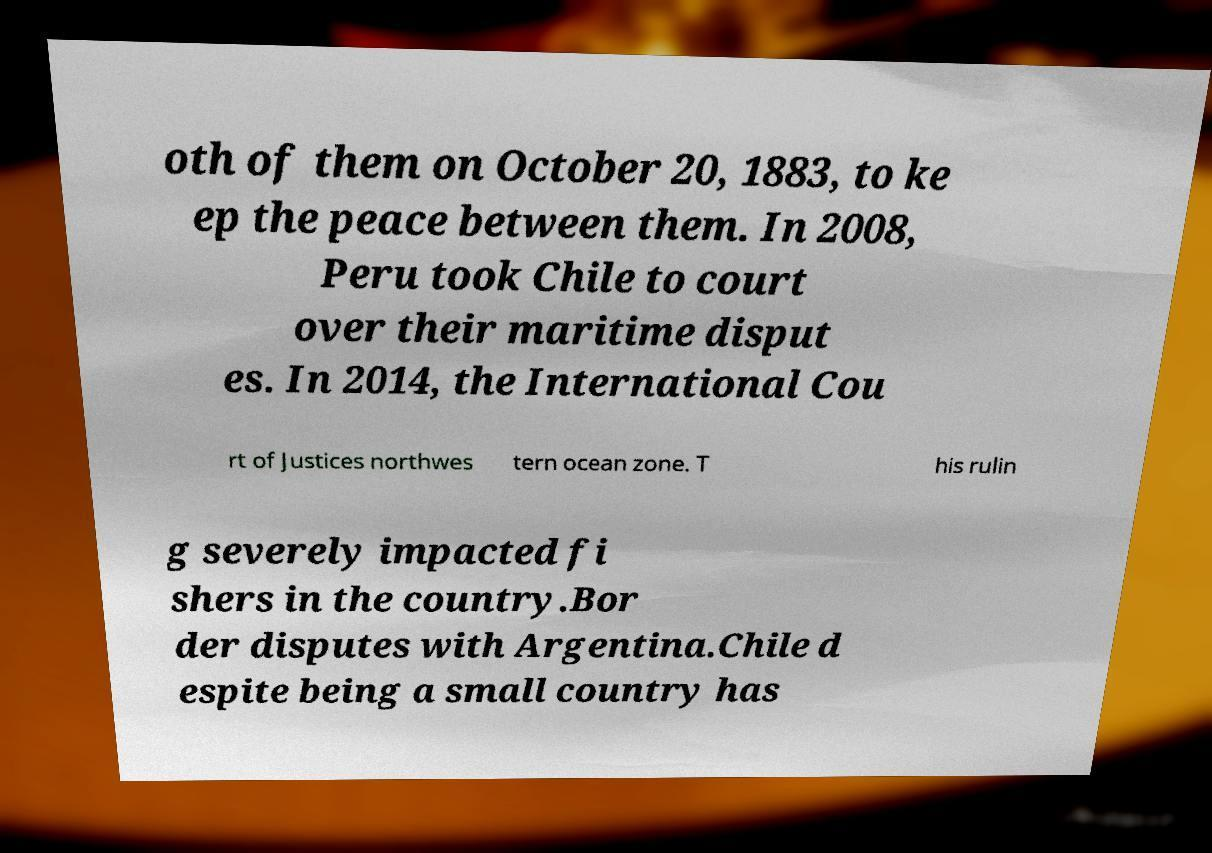Can you accurately transcribe the text from the provided image for me? oth of them on October 20, 1883, to ke ep the peace between them. In 2008, Peru took Chile to court over their maritime disput es. In 2014, the International Cou rt of Justices northwes tern ocean zone. T his rulin g severely impacted fi shers in the country.Bor der disputes with Argentina.Chile d espite being a small country has 